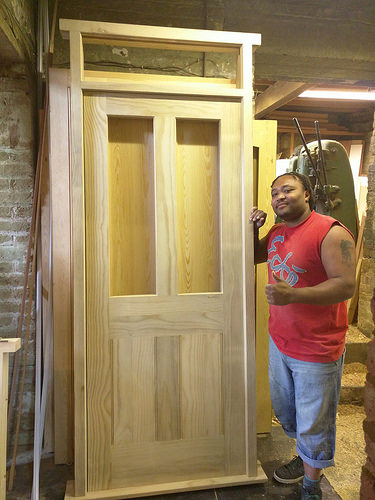<image>
Is the man next to the door? Yes. The man is positioned adjacent to the door, located nearby in the same general area. Where is the man in relation to the door? Is it to the left of the door? No. The man is not to the left of the door. From this viewpoint, they have a different horizontal relationship. 